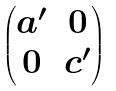Convert formula to latex. <formula><loc_0><loc_0><loc_500><loc_500>\begin{pmatrix} a ^ { \prime } & 0 \\ 0 & c ^ { \prime } \end{pmatrix}</formula> 